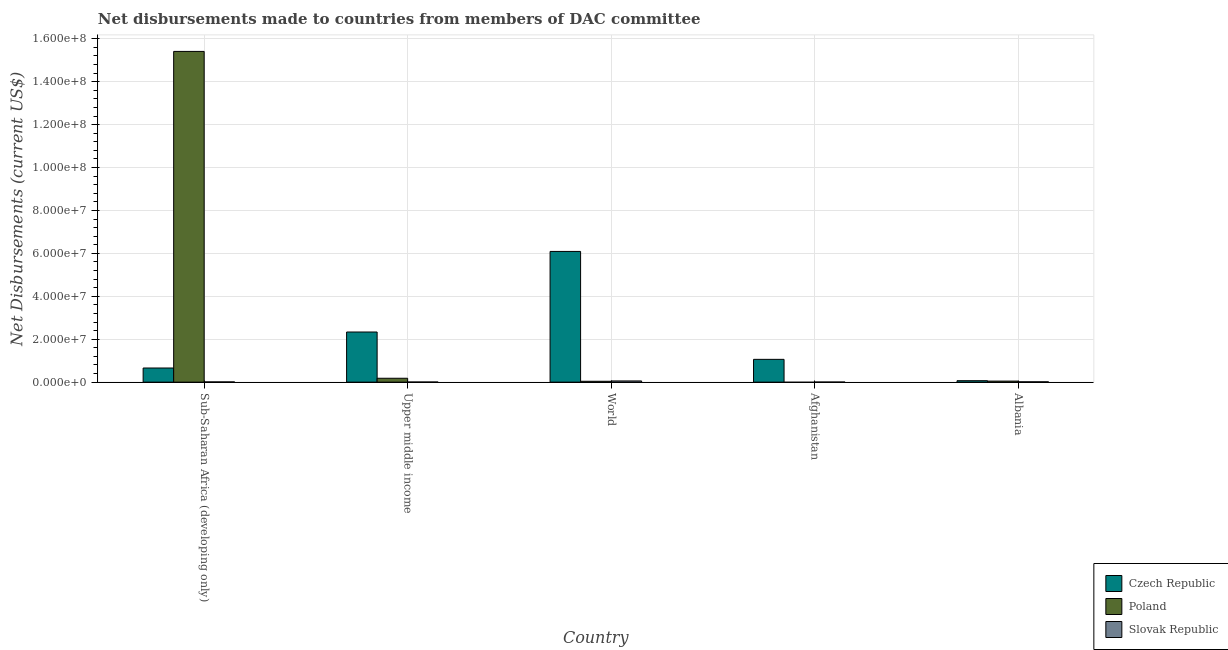How many groups of bars are there?
Offer a terse response. 5. Are the number of bars per tick equal to the number of legend labels?
Ensure brevity in your answer.  No. How many bars are there on the 4th tick from the left?
Make the answer very short. 2. What is the label of the 5th group of bars from the left?
Ensure brevity in your answer.  Albania. What is the net disbursements made by czech republic in World?
Provide a short and direct response. 6.09e+07. Across all countries, what is the maximum net disbursements made by czech republic?
Give a very brief answer. 6.09e+07. Across all countries, what is the minimum net disbursements made by czech republic?
Your response must be concise. 6.80e+05. In which country was the net disbursements made by slovak republic maximum?
Provide a short and direct response. World. What is the total net disbursements made by slovak republic in the graph?
Keep it short and to the point. 9.30e+05. What is the difference between the net disbursements made by czech republic in Sub-Saharan Africa (developing only) and that in Upper middle income?
Your answer should be compact. -1.68e+07. What is the difference between the net disbursements made by poland in Sub-Saharan Africa (developing only) and the net disbursements made by czech republic in Upper middle income?
Your answer should be very brief. 1.31e+08. What is the average net disbursements made by czech republic per country?
Your answer should be compact. 2.04e+07. What is the difference between the net disbursements made by poland and net disbursements made by slovak republic in Upper middle income?
Provide a short and direct response. 1.75e+06. What is the ratio of the net disbursements made by czech republic in Afghanistan to that in Albania?
Offer a very short reply. 15.62. Is the difference between the net disbursements made by czech republic in Upper middle income and World greater than the difference between the net disbursements made by poland in Upper middle income and World?
Provide a short and direct response. No. What is the difference between the highest and the second highest net disbursements made by poland?
Ensure brevity in your answer.  1.52e+08. What is the difference between the highest and the lowest net disbursements made by poland?
Make the answer very short. 1.54e+08. Is the sum of the net disbursements made by czech republic in Albania and Sub-Saharan Africa (developing only) greater than the maximum net disbursements made by slovak republic across all countries?
Keep it short and to the point. Yes. How many bars are there?
Your answer should be very brief. 14. How many countries are there in the graph?
Your answer should be compact. 5. Are the values on the major ticks of Y-axis written in scientific E-notation?
Provide a succinct answer. Yes. Does the graph contain grids?
Offer a very short reply. Yes. How many legend labels are there?
Give a very brief answer. 3. How are the legend labels stacked?
Keep it short and to the point. Vertical. What is the title of the graph?
Make the answer very short. Net disbursements made to countries from members of DAC committee. What is the label or title of the Y-axis?
Provide a succinct answer. Net Disbursements (current US$). What is the Net Disbursements (current US$) of Czech Republic in Sub-Saharan Africa (developing only)?
Keep it short and to the point. 6.59e+06. What is the Net Disbursements (current US$) in Poland in Sub-Saharan Africa (developing only)?
Offer a terse response. 1.54e+08. What is the Net Disbursements (current US$) in Czech Republic in Upper middle income?
Provide a succinct answer. 2.34e+07. What is the Net Disbursements (current US$) in Poland in Upper middle income?
Make the answer very short. 1.81e+06. What is the Net Disbursements (current US$) of Slovak Republic in Upper middle income?
Offer a terse response. 6.00e+04. What is the Net Disbursements (current US$) in Czech Republic in World?
Offer a terse response. 6.09e+07. What is the Net Disbursements (current US$) in Slovak Republic in World?
Provide a succinct answer. 5.60e+05. What is the Net Disbursements (current US$) in Czech Republic in Afghanistan?
Provide a succinct answer. 1.06e+07. What is the Net Disbursements (current US$) in Czech Republic in Albania?
Your answer should be very brief. 6.80e+05. What is the Net Disbursements (current US$) in Slovak Republic in Albania?
Ensure brevity in your answer.  1.60e+05. Across all countries, what is the maximum Net Disbursements (current US$) of Czech Republic?
Give a very brief answer. 6.09e+07. Across all countries, what is the maximum Net Disbursements (current US$) of Poland?
Keep it short and to the point. 1.54e+08. Across all countries, what is the maximum Net Disbursements (current US$) of Slovak Republic?
Provide a short and direct response. 5.60e+05. Across all countries, what is the minimum Net Disbursements (current US$) of Czech Republic?
Provide a short and direct response. 6.80e+05. What is the total Net Disbursements (current US$) of Czech Republic in the graph?
Make the answer very short. 1.02e+08. What is the total Net Disbursements (current US$) of Poland in the graph?
Offer a terse response. 1.57e+08. What is the total Net Disbursements (current US$) in Slovak Republic in the graph?
Offer a very short reply. 9.30e+05. What is the difference between the Net Disbursements (current US$) in Czech Republic in Sub-Saharan Africa (developing only) and that in Upper middle income?
Your answer should be compact. -1.68e+07. What is the difference between the Net Disbursements (current US$) of Poland in Sub-Saharan Africa (developing only) and that in Upper middle income?
Your response must be concise. 1.52e+08. What is the difference between the Net Disbursements (current US$) in Slovak Republic in Sub-Saharan Africa (developing only) and that in Upper middle income?
Your answer should be compact. 5.00e+04. What is the difference between the Net Disbursements (current US$) of Czech Republic in Sub-Saharan Africa (developing only) and that in World?
Provide a succinct answer. -5.43e+07. What is the difference between the Net Disbursements (current US$) of Poland in Sub-Saharan Africa (developing only) and that in World?
Ensure brevity in your answer.  1.54e+08. What is the difference between the Net Disbursements (current US$) in Slovak Republic in Sub-Saharan Africa (developing only) and that in World?
Your answer should be compact. -4.50e+05. What is the difference between the Net Disbursements (current US$) of Czech Republic in Sub-Saharan Africa (developing only) and that in Afghanistan?
Provide a short and direct response. -4.03e+06. What is the difference between the Net Disbursements (current US$) of Slovak Republic in Sub-Saharan Africa (developing only) and that in Afghanistan?
Offer a terse response. 7.00e+04. What is the difference between the Net Disbursements (current US$) of Czech Republic in Sub-Saharan Africa (developing only) and that in Albania?
Ensure brevity in your answer.  5.91e+06. What is the difference between the Net Disbursements (current US$) in Poland in Sub-Saharan Africa (developing only) and that in Albania?
Your answer should be very brief. 1.54e+08. What is the difference between the Net Disbursements (current US$) of Czech Republic in Upper middle income and that in World?
Provide a succinct answer. -3.76e+07. What is the difference between the Net Disbursements (current US$) of Poland in Upper middle income and that in World?
Provide a succinct answer. 1.40e+06. What is the difference between the Net Disbursements (current US$) of Slovak Republic in Upper middle income and that in World?
Offer a terse response. -5.00e+05. What is the difference between the Net Disbursements (current US$) in Czech Republic in Upper middle income and that in Afghanistan?
Ensure brevity in your answer.  1.27e+07. What is the difference between the Net Disbursements (current US$) of Slovak Republic in Upper middle income and that in Afghanistan?
Make the answer very short. 2.00e+04. What is the difference between the Net Disbursements (current US$) in Czech Republic in Upper middle income and that in Albania?
Provide a short and direct response. 2.27e+07. What is the difference between the Net Disbursements (current US$) of Poland in Upper middle income and that in Albania?
Make the answer very short. 1.32e+06. What is the difference between the Net Disbursements (current US$) in Slovak Republic in Upper middle income and that in Albania?
Offer a very short reply. -1.00e+05. What is the difference between the Net Disbursements (current US$) of Czech Republic in World and that in Afghanistan?
Your answer should be very brief. 5.03e+07. What is the difference between the Net Disbursements (current US$) of Slovak Republic in World and that in Afghanistan?
Provide a succinct answer. 5.20e+05. What is the difference between the Net Disbursements (current US$) of Czech Republic in World and that in Albania?
Your answer should be very brief. 6.02e+07. What is the difference between the Net Disbursements (current US$) of Slovak Republic in World and that in Albania?
Offer a very short reply. 4.00e+05. What is the difference between the Net Disbursements (current US$) in Czech Republic in Afghanistan and that in Albania?
Ensure brevity in your answer.  9.94e+06. What is the difference between the Net Disbursements (current US$) in Czech Republic in Sub-Saharan Africa (developing only) and the Net Disbursements (current US$) in Poland in Upper middle income?
Ensure brevity in your answer.  4.78e+06. What is the difference between the Net Disbursements (current US$) of Czech Republic in Sub-Saharan Africa (developing only) and the Net Disbursements (current US$) of Slovak Republic in Upper middle income?
Your answer should be compact. 6.53e+06. What is the difference between the Net Disbursements (current US$) of Poland in Sub-Saharan Africa (developing only) and the Net Disbursements (current US$) of Slovak Republic in Upper middle income?
Offer a terse response. 1.54e+08. What is the difference between the Net Disbursements (current US$) in Czech Republic in Sub-Saharan Africa (developing only) and the Net Disbursements (current US$) in Poland in World?
Give a very brief answer. 6.18e+06. What is the difference between the Net Disbursements (current US$) in Czech Republic in Sub-Saharan Africa (developing only) and the Net Disbursements (current US$) in Slovak Republic in World?
Provide a short and direct response. 6.03e+06. What is the difference between the Net Disbursements (current US$) in Poland in Sub-Saharan Africa (developing only) and the Net Disbursements (current US$) in Slovak Republic in World?
Your answer should be compact. 1.54e+08. What is the difference between the Net Disbursements (current US$) of Czech Republic in Sub-Saharan Africa (developing only) and the Net Disbursements (current US$) of Slovak Republic in Afghanistan?
Provide a succinct answer. 6.55e+06. What is the difference between the Net Disbursements (current US$) of Poland in Sub-Saharan Africa (developing only) and the Net Disbursements (current US$) of Slovak Republic in Afghanistan?
Give a very brief answer. 1.54e+08. What is the difference between the Net Disbursements (current US$) in Czech Republic in Sub-Saharan Africa (developing only) and the Net Disbursements (current US$) in Poland in Albania?
Your response must be concise. 6.10e+06. What is the difference between the Net Disbursements (current US$) in Czech Republic in Sub-Saharan Africa (developing only) and the Net Disbursements (current US$) in Slovak Republic in Albania?
Your answer should be very brief. 6.43e+06. What is the difference between the Net Disbursements (current US$) of Poland in Sub-Saharan Africa (developing only) and the Net Disbursements (current US$) of Slovak Republic in Albania?
Ensure brevity in your answer.  1.54e+08. What is the difference between the Net Disbursements (current US$) of Czech Republic in Upper middle income and the Net Disbursements (current US$) of Poland in World?
Make the answer very short. 2.30e+07. What is the difference between the Net Disbursements (current US$) in Czech Republic in Upper middle income and the Net Disbursements (current US$) in Slovak Republic in World?
Your response must be concise. 2.28e+07. What is the difference between the Net Disbursements (current US$) of Poland in Upper middle income and the Net Disbursements (current US$) of Slovak Republic in World?
Your response must be concise. 1.25e+06. What is the difference between the Net Disbursements (current US$) in Czech Republic in Upper middle income and the Net Disbursements (current US$) in Slovak Republic in Afghanistan?
Keep it short and to the point. 2.33e+07. What is the difference between the Net Disbursements (current US$) in Poland in Upper middle income and the Net Disbursements (current US$) in Slovak Republic in Afghanistan?
Your answer should be very brief. 1.77e+06. What is the difference between the Net Disbursements (current US$) of Czech Republic in Upper middle income and the Net Disbursements (current US$) of Poland in Albania?
Your answer should be compact. 2.29e+07. What is the difference between the Net Disbursements (current US$) in Czech Republic in Upper middle income and the Net Disbursements (current US$) in Slovak Republic in Albania?
Your answer should be very brief. 2.32e+07. What is the difference between the Net Disbursements (current US$) in Poland in Upper middle income and the Net Disbursements (current US$) in Slovak Republic in Albania?
Offer a very short reply. 1.65e+06. What is the difference between the Net Disbursements (current US$) of Czech Republic in World and the Net Disbursements (current US$) of Slovak Republic in Afghanistan?
Your answer should be very brief. 6.09e+07. What is the difference between the Net Disbursements (current US$) in Poland in World and the Net Disbursements (current US$) in Slovak Republic in Afghanistan?
Offer a terse response. 3.70e+05. What is the difference between the Net Disbursements (current US$) of Czech Republic in World and the Net Disbursements (current US$) of Poland in Albania?
Provide a short and direct response. 6.04e+07. What is the difference between the Net Disbursements (current US$) in Czech Republic in World and the Net Disbursements (current US$) in Slovak Republic in Albania?
Make the answer very short. 6.08e+07. What is the difference between the Net Disbursements (current US$) of Poland in World and the Net Disbursements (current US$) of Slovak Republic in Albania?
Ensure brevity in your answer.  2.50e+05. What is the difference between the Net Disbursements (current US$) in Czech Republic in Afghanistan and the Net Disbursements (current US$) in Poland in Albania?
Keep it short and to the point. 1.01e+07. What is the difference between the Net Disbursements (current US$) of Czech Republic in Afghanistan and the Net Disbursements (current US$) of Slovak Republic in Albania?
Your answer should be compact. 1.05e+07. What is the average Net Disbursements (current US$) of Czech Republic per country?
Give a very brief answer. 2.04e+07. What is the average Net Disbursements (current US$) in Poland per country?
Make the answer very short. 3.14e+07. What is the average Net Disbursements (current US$) of Slovak Republic per country?
Your response must be concise. 1.86e+05. What is the difference between the Net Disbursements (current US$) in Czech Republic and Net Disbursements (current US$) in Poland in Sub-Saharan Africa (developing only)?
Offer a terse response. -1.48e+08. What is the difference between the Net Disbursements (current US$) in Czech Republic and Net Disbursements (current US$) in Slovak Republic in Sub-Saharan Africa (developing only)?
Provide a short and direct response. 6.48e+06. What is the difference between the Net Disbursements (current US$) of Poland and Net Disbursements (current US$) of Slovak Republic in Sub-Saharan Africa (developing only)?
Your answer should be compact. 1.54e+08. What is the difference between the Net Disbursements (current US$) of Czech Republic and Net Disbursements (current US$) of Poland in Upper middle income?
Provide a succinct answer. 2.16e+07. What is the difference between the Net Disbursements (current US$) in Czech Republic and Net Disbursements (current US$) in Slovak Republic in Upper middle income?
Give a very brief answer. 2.33e+07. What is the difference between the Net Disbursements (current US$) of Poland and Net Disbursements (current US$) of Slovak Republic in Upper middle income?
Your answer should be very brief. 1.75e+06. What is the difference between the Net Disbursements (current US$) in Czech Republic and Net Disbursements (current US$) in Poland in World?
Offer a terse response. 6.05e+07. What is the difference between the Net Disbursements (current US$) of Czech Republic and Net Disbursements (current US$) of Slovak Republic in World?
Your response must be concise. 6.04e+07. What is the difference between the Net Disbursements (current US$) of Czech Republic and Net Disbursements (current US$) of Slovak Republic in Afghanistan?
Keep it short and to the point. 1.06e+07. What is the difference between the Net Disbursements (current US$) in Czech Republic and Net Disbursements (current US$) in Poland in Albania?
Provide a succinct answer. 1.90e+05. What is the difference between the Net Disbursements (current US$) of Czech Republic and Net Disbursements (current US$) of Slovak Republic in Albania?
Make the answer very short. 5.20e+05. What is the ratio of the Net Disbursements (current US$) of Czech Republic in Sub-Saharan Africa (developing only) to that in Upper middle income?
Ensure brevity in your answer.  0.28. What is the ratio of the Net Disbursements (current US$) in Poland in Sub-Saharan Africa (developing only) to that in Upper middle income?
Provide a short and direct response. 85.14. What is the ratio of the Net Disbursements (current US$) in Slovak Republic in Sub-Saharan Africa (developing only) to that in Upper middle income?
Offer a terse response. 1.83. What is the ratio of the Net Disbursements (current US$) of Czech Republic in Sub-Saharan Africa (developing only) to that in World?
Your response must be concise. 0.11. What is the ratio of the Net Disbursements (current US$) in Poland in Sub-Saharan Africa (developing only) to that in World?
Offer a very short reply. 375.88. What is the ratio of the Net Disbursements (current US$) in Slovak Republic in Sub-Saharan Africa (developing only) to that in World?
Offer a very short reply. 0.2. What is the ratio of the Net Disbursements (current US$) in Czech Republic in Sub-Saharan Africa (developing only) to that in Afghanistan?
Make the answer very short. 0.62. What is the ratio of the Net Disbursements (current US$) of Slovak Republic in Sub-Saharan Africa (developing only) to that in Afghanistan?
Your answer should be very brief. 2.75. What is the ratio of the Net Disbursements (current US$) in Czech Republic in Sub-Saharan Africa (developing only) to that in Albania?
Provide a succinct answer. 9.69. What is the ratio of the Net Disbursements (current US$) in Poland in Sub-Saharan Africa (developing only) to that in Albania?
Provide a short and direct response. 314.51. What is the ratio of the Net Disbursements (current US$) in Slovak Republic in Sub-Saharan Africa (developing only) to that in Albania?
Offer a very short reply. 0.69. What is the ratio of the Net Disbursements (current US$) of Czech Republic in Upper middle income to that in World?
Give a very brief answer. 0.38. What is the ratio of the Net Disbursements (current US$) in Poland in Upper middle income to that in World?
Offer a very short reply. 4.41. What is the ratio of the Net Disbursements (current US$) of Slovak Republic in Upper middle income to that in World?
Provide a succinct answer. 0.11. What is the ratio of the Net Disbursements (current US$) of Czech Republic in Upper middle income to that in Afghanistan?
Give a very brief answer. 2.2. What is the ratio of the Net Disbursements (current US$) in Slovak Republic in Upper middle income to that in Afghanistan?
Keep it short and to the point. 1.5. What is the ratio of the Net Disbursements (current US$) in Czech Republic in Upper middle income to that in Albania?
Offer a very short reply. 34.35. What is the ratio of the Net Disbursements (current US$) in Poland in Upper middle income to that in Albania?
Offer a very short reply. 3.69. What is the ratio of the Net Disbursements (current US$) in Slovak Republic in Upper middle income to that in Albania?
Provide a short and direct response. 0.38. What is the ratio of the Net Disbursements (current US$) of Czech Republic in World to that in Afghanistan?
Give a very brief answer. 5.74. What is the ratio of the Net Disbursements (current US$) of Slovak Republic in World to that in Afghanistan?
Your response must be concise. 14. What is the ratio of the Net Disbursements (current US$) of Czech Republic in World to that in Albania?
Provide a short and direct response. 89.57. What is the ratio of the Net Disbursements (current US$) in Poland in World to that in Albania?
Provide a short and direct response. 0.84. What is the ratio of the Net Disbursements (current US$) of Czech Republic in Afghanistan to that in Albania?
Give a very brief answer. 15.62. What is the difference between the highest and the second highest Net Disbursements (current US$) in Czech Republic?
Your response must be concise. 3.76e+07. What is the difference between the highest and the second highest Net Disbursements (current US$) in Poland?
Ensure brevity in your answer.  1.52e+08. What is the difference between the highest and the lowest Net Disbursements (current US$) in Czech Republic?
Make the answer very short. 6.02e+07. What is the difference between the highest and the lowest Net Disbursements (current US$) of Poland?
Your answer should be very brief. 1.54e+08. What is the difference between the highest and the lowest Net Disbursements (current US$) in Slovak Republic?
Make the answer very short. 5.20e+05. 